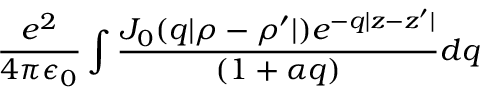<formula> <loc_0><loc_0><loc_500><loc_500>\frac { e ^ { 2 } } { 4 \pi \epsilon _ { 0 } } \int \frac { J _ { 0 } ( q | \rho - \rho ^ { \prime } | ) e ^ { - q | z - z ^ { \prime } | } } { ( 1 + \alpha q ) } d q</formula> 